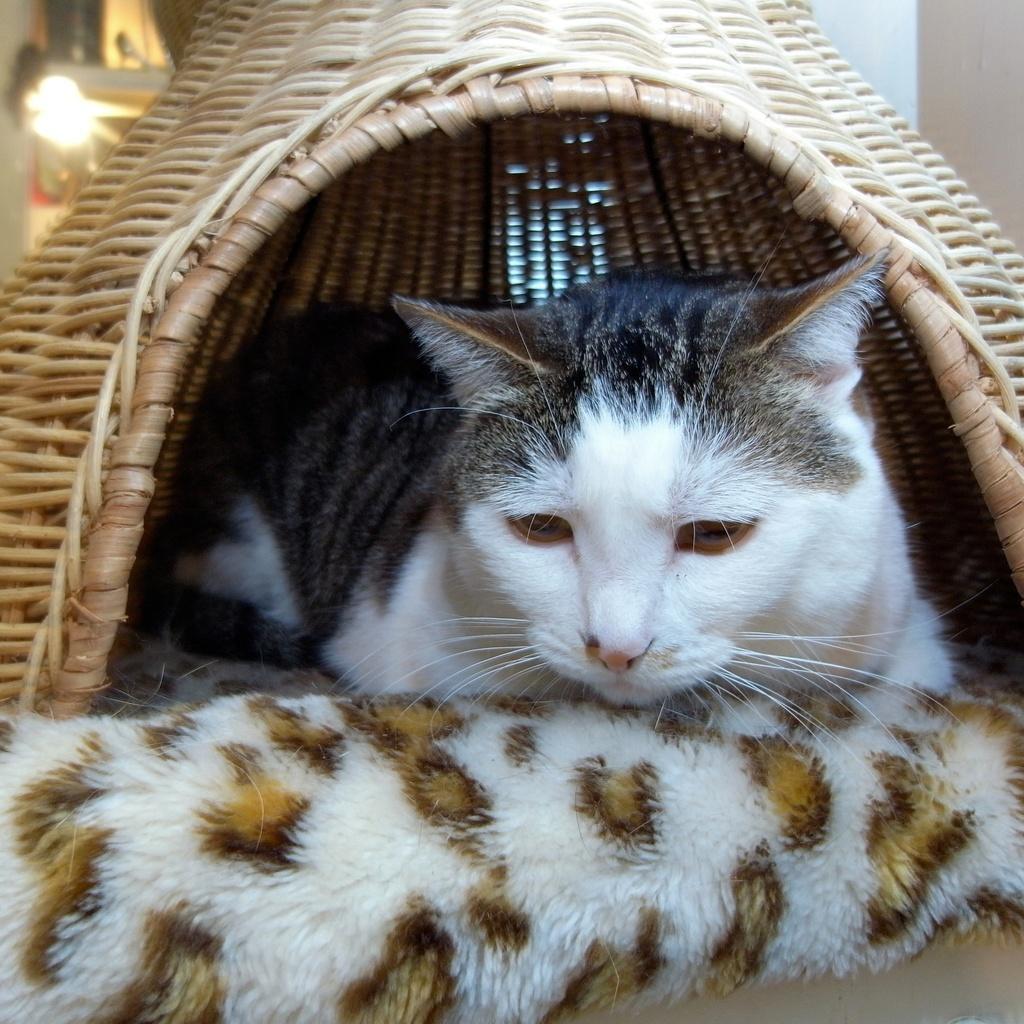How would you summarize this image in a sentence or two? In this image I can see a cat which is black, grey and white in color is under the wooden object. I can see a cloth which is cream and brown in color. In the background I can see a light, the wall and few other objects. 